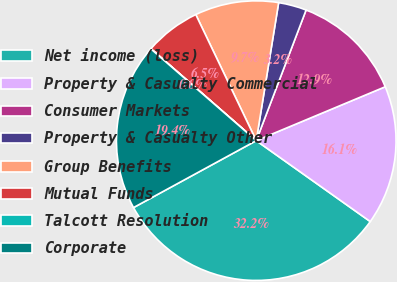<chart> <loc_0><loc_0><loc_500><loc_500><pie_chart><fcel>Net income (loss)<fcel>Property & Casualty Commercial<fcel>Consumer Markets<fcel>Property & Casualty Other<fcel>Group Benefits<fcel>Mutual Funds<fcel>Talcott Resolution<fcel>Corporate<nl><fcel>32.23%<fcel>16.12%<fcel>12.9%<fcel>3.24%<fcel>9.68%<fcel>6.46%<fcel>0.02%<fcel>19.35%<nl></chart> 